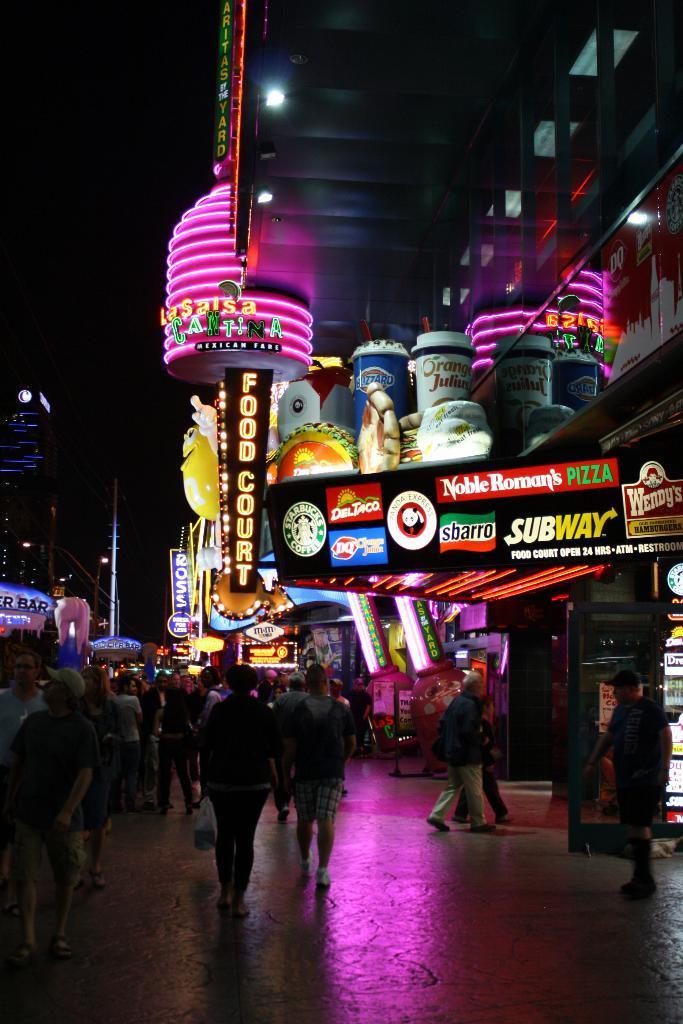Please provide a concise description of this image. In this image we can see the night view of the street and we can see some people and there are some buildings and we can see some boards with the text and at the top we can see the sky. 